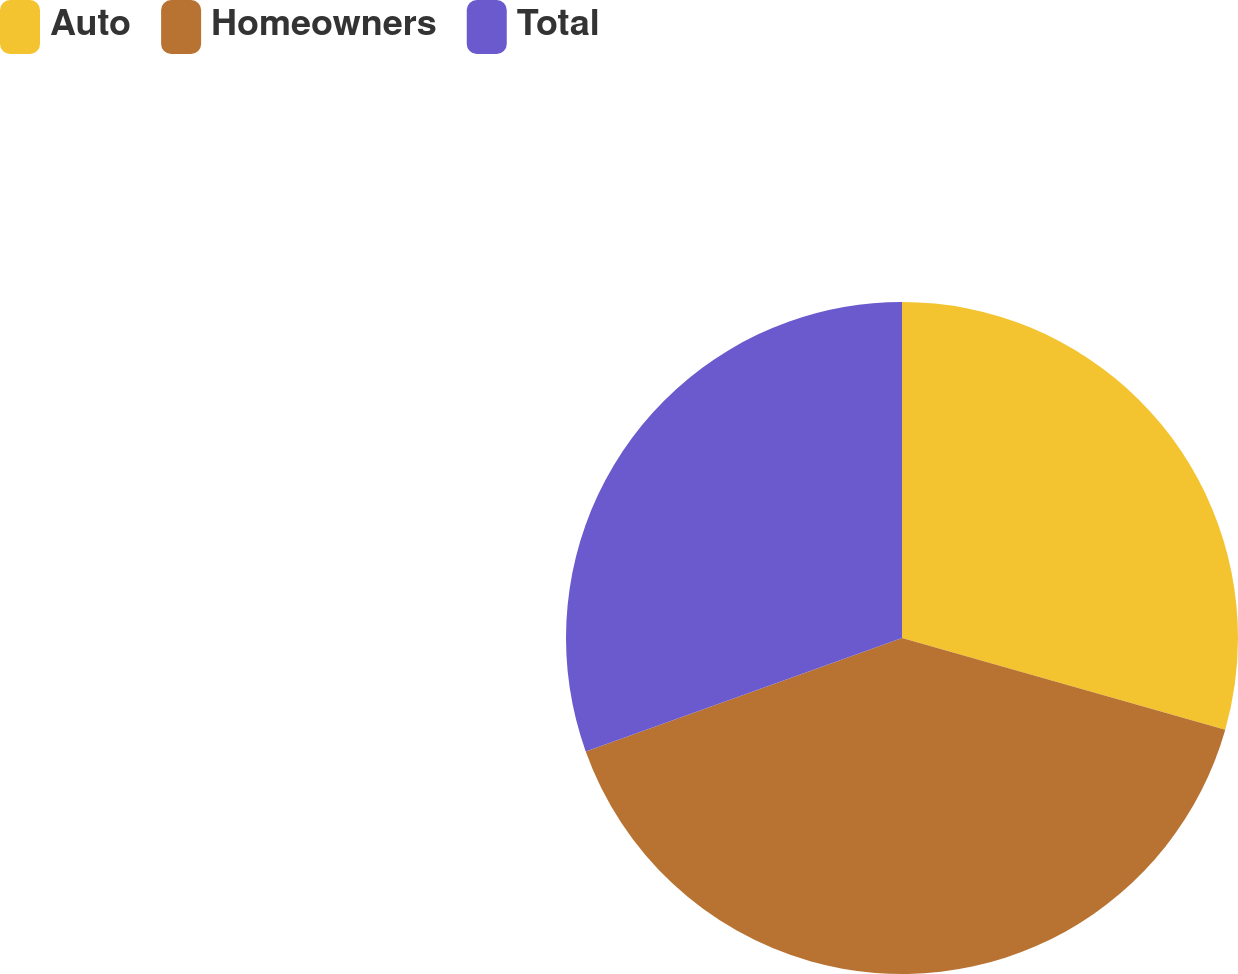<chart> <loc_0><loc_0><loc_500><loc_500><pie_chart><fcel>Auto<fcel>Homeowners<fcel>Total<nl><fcel>29.4%<fcel>40.12%<fcel>30.48%<nl></chart> 